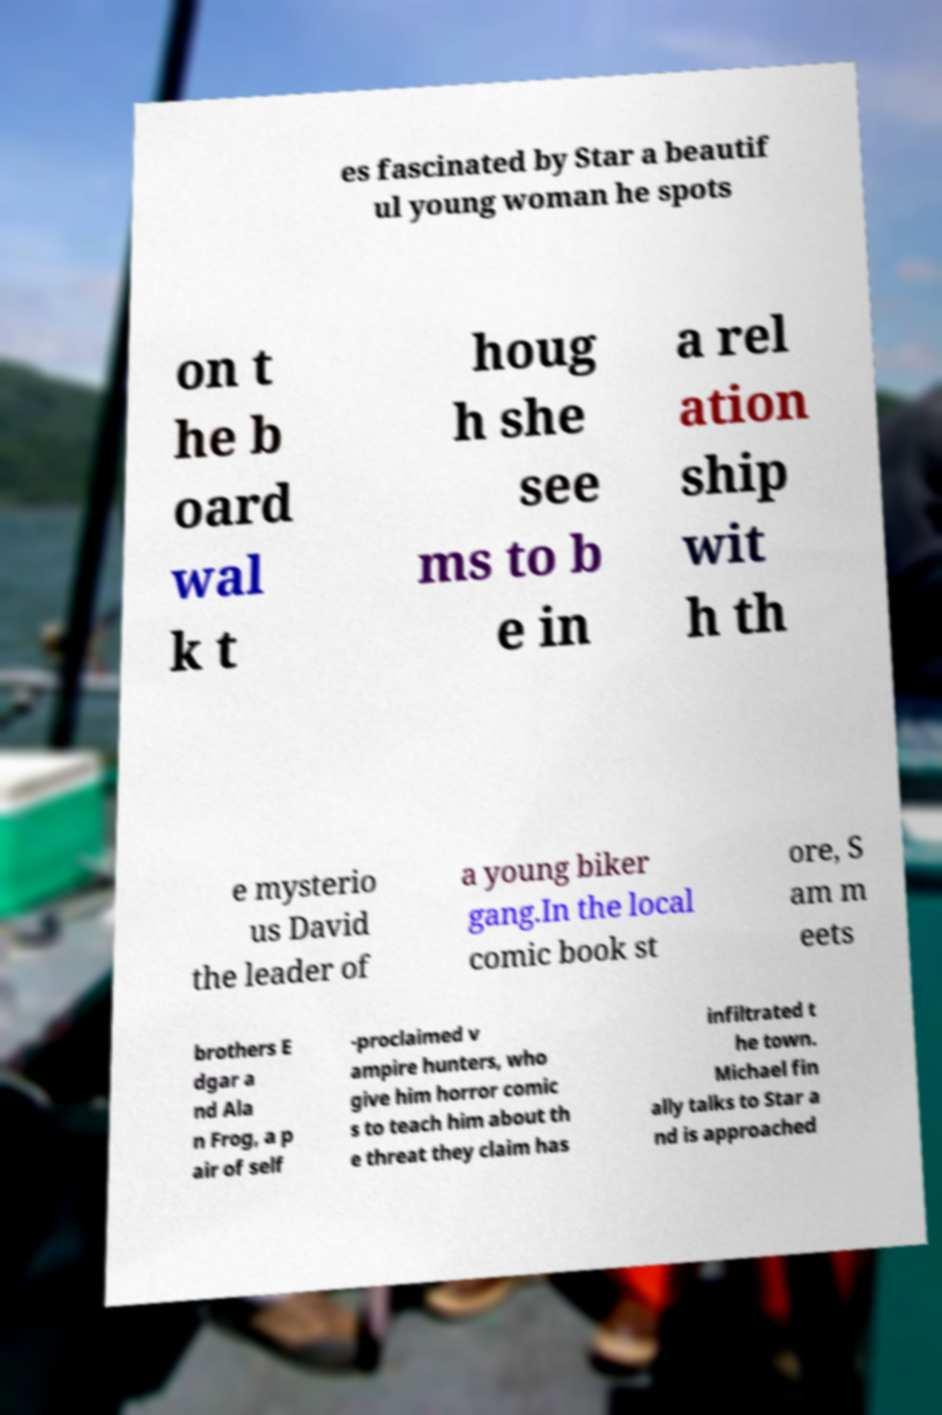What messages or text are displayed in this image? I need them in a readable, typed format. es fascinated by Star a beautif ul young woman he spots on t he b oard wal k t houg h she see ms to b e in a rel ation ship wit h th e mysterio us David the leader of a young biker gang.In the local comic book st ore, S am m eets brothers E dgar a nd Ala n Frog, a p air of self -proclaimed v ampire hunters, who give him horror comic s to teach him about th e threat they claim has infiltrated t he town. Michael fin ally talks to Star a nd is approached 